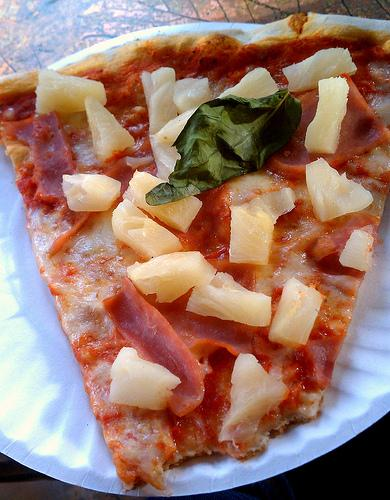Provide a brief interpretation of the image as a whole. An image of a half-eaten thin crust pizza slice loaded with toppings sitting on a white paper plate on a brown table. Describe the pizza and its placement. A thin crust pizza slice with various toppings is placed on a white paper plate with bite marks visible. What can one infer about the meal in the image? The image shows a half-eaten pizza slice with various toppings, suggesting that someone is enjoying a meal. Explain the scene that is portrayed in the photograph. A half-consumed thin crust pizza with toppings like ham, pineapple, cheese, and basil leaves is resting on a white paper plate. What type of pizza is showcased in the image and which toppings can be found on it? A thin crust pizza slice with toppings such as ham, pineapple, cheese, basil leaves, and tomato sauce. Mention the primary item in the image along with its major toppings. A slice of pizza on a white paper plate with ham, pineapple, cheese, and basil leaf toppings. What food item is present in the image and what are its main ingredients? A pizza slice is present, featuring ham, pineapple, cheese, basil leaves, and tomato sauce as its main ingredients. Briefly discuss the state of the pizza in the picture. The pizza looks partially eaten, with some bite marks visible on the crust. Outline the primary components of the image. The image features a pizza slice on a white paper plate with ham, pineapple, cheese, basil leaves, and tomato sauce toppings. Summarize the visuals in the image. A thin crust pizza slice with bite marks, loaded with toppings, is presented on a white paper plate on a brown surface. 